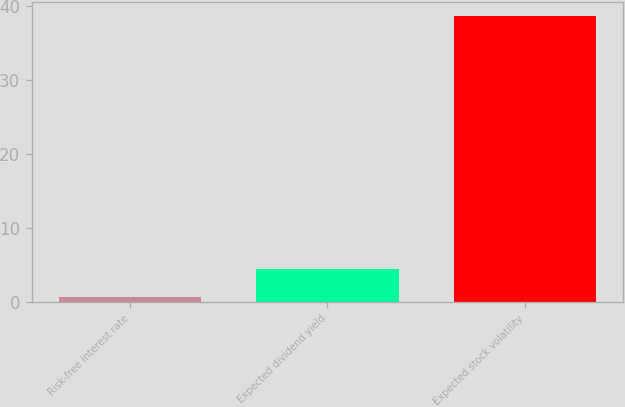Convert chart. <chart><loc_0><loc_0><loc_500><loc_500><bar_chart><fcel>Risk-free interest rate<fcel>Expected dividend yield<fcel>Expected stock volatility<nl><fcel>0.6<fcel>4.41<fcel>38.7<nl></chart> 